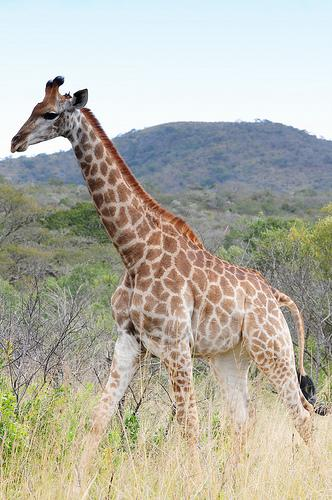Question: what animal is in this picture?
Choices:
A. A zebra.
B. A lion.
C. A horse.
D. A giraffe.
Answer with the letter. Answer: D Question: what is this animal doing?
Choices:
A. Lying down.
B. Standing.
C. Stretching.
D. Eating.
Answer with the letter. Answer: B Question: how many legs can you see?
Choices:
A. Five.
B. Three.
C. Six.
D. Four.
Answer with the letter. Answer: D Question: where was this picture taken?
Choices:
A. In the safari.
B. The Eastern steppes.
C. In a dystopian future.
D. At a parking lot.
Answer with the letter. Answer: A 